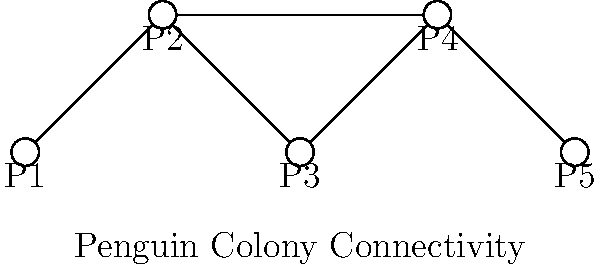In the graph representing penguin colonies in Antarctica, each node represents a colony and each edge represents a possible route between colonies. If you need to establish a monitoring system that covers all colonies but uses the minimum number of routes, how many routes (edges) should be included in the system? To solve this problem, we need to find the minimum spanning tree of the graph. A minimum spanning tree is a subset of edges that connects all vertices with the minimum total number of edges. Here's how we can approach this:

1. Count the total number of vertices (colonies): There are 5 vertices (P1, P2, P3, P4, P5).

2. Recall that in a minimum spanning tree, the number of edges is always equal to the number of vertices minus 1. This is because we need just enough edges to connect all vertices without creating any cycles.

3. Therefore, the number of edges in the minimum spanning tree (and thus the number of routes needed) is:
   $$ \text{Number of edges} = \text{Number of vertices} - 1 $$
   $$ \text{Number of edges} = 5 - 1 = 4 $$

4. We can verify this by looking at the graph:
   - We need the edge P1-P2 to connect P1
   - We need the edge P2-P3 to connect P3
   - We need the edge P3-P4 to connect P4
   - We need the edge P4-P5 to connect P5

This gives us a total of 4 edges, which connects all colonies using the minimum number of routes.
Answer: 4 routes 